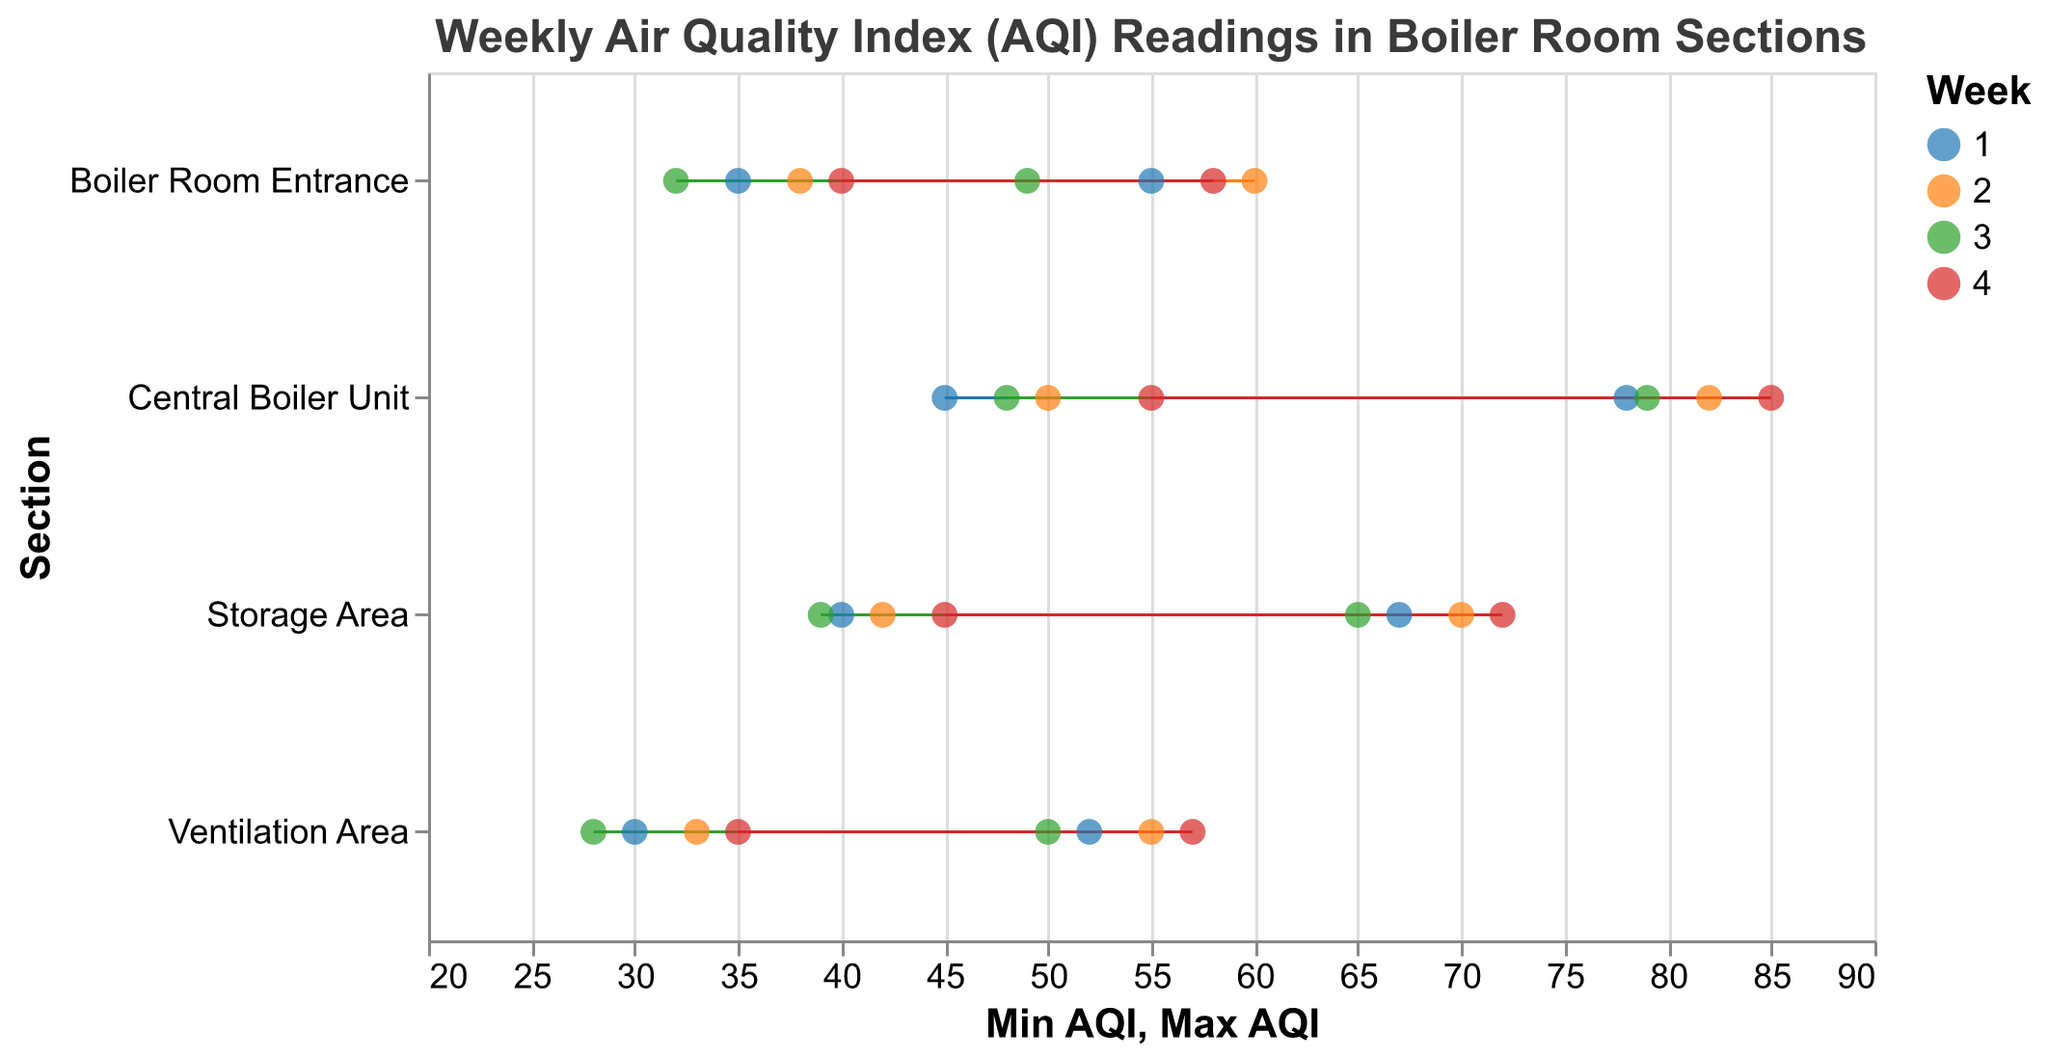What is the title of the plot? The title is displayed at the top of the plot and provides an overall description of what the data represents.
Answer: Weekly Air Quality Index (AQI) Readings in Boiler Room Sections Which section has the highest maximum AQI reading in week 4? By examining the plot, we can see that the Central Boiler Unit has the highest maximum AQI reading for week 4, reaching 85.
Answer: Central Boiler Unit What is the range of AQI readings for the Storage Area in week 2? The range is calculated by subtracting the minimum AQI from the maximum AQI for the given week. For week 2 in the Storage Area, the range is 70 - 42 = 28.
Answer: 28 Which section has the smallest minimum AQI reading over the weeks? By comparing the minimum AQI readings for all sections across all weeks, we can see that the Ventilation Area in week 3 has the smallest minimum AQI reading of 28.
Answer: Ventilation Area How does the range of AQI readings for the Boiler Room Entrance in week 2 compare to week 3? The range for week 2 is calculated as 60 - 38 = 22, and for week 3 it is 49 - 32 = 17. The range in week 2 is 5 units greater than in week 3.
Answer: Week 2's range is 5 units greater than Week 3's What is the average maximum AQI reading for the Central Boiler Unit over the 4 weeks? Sum the maximum AQI readings for the 4 weeks (78 + 82 + 79 + 85 = 324) and divide by 4 to get the average, which is 324 / 4 = 81.
Answer: 81 Which section and week show the largest difference between the minimum and maximum AQI readings? By evaluating each difference, the largest difference found is in the Central Boiler Unit in week 4 with a range of 85 - 55 = 30.
Answer: Central Boiler Unit, Week 4 Is there any section where the AQI range decreases consistently across all weeks? By examining the plot, we notice that the Boiler Room Entrance has a range of 20 (week 1), 22 (week 2), 17 (week 3), and 18 (week 4). The pattern is not consistently decreasing.
Answer: No Which week shows the highest variation in AQI readings across all sections? Calculating the range for each section for each week, week 4 has ranges: Boiler Room Entrance (18), Central Boiler Unit (30), Ventilation Area (22), and Storage Area (27). The highest variation is Central Boiler Unit with 30 in week 4.
Answer: Week 4 